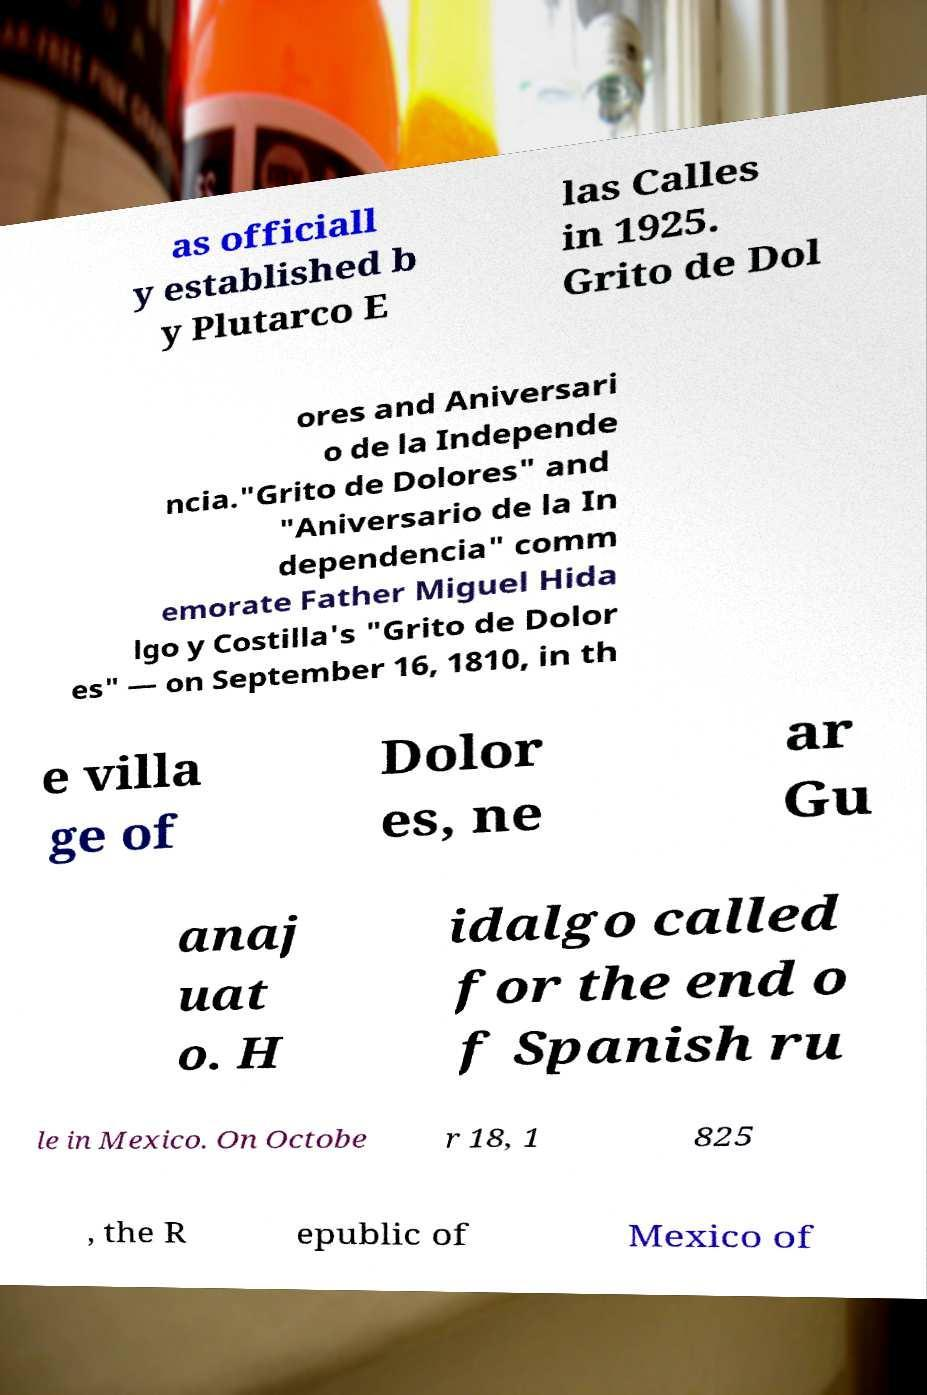I need the written content from this picture converted into text. Can you do that? as officiall y established b y Plutarco E las Calles in 1925. Grito de Dol ores and Aniversari o de la Independe ncia."Grito de Dolores" and "Aniversario de la In dependencia" comm emorate Father Miguel Hida lgo y Costilla's "Grito de Dolor es" — on September 16, 1810, in th e villa ge of Dolor es, ne ar Gu anaj uat o. H idalgo called for the end o f Spanish ru le in Mexico. On Octobe r 18, 1 825 , the R epublic of Mexico of 